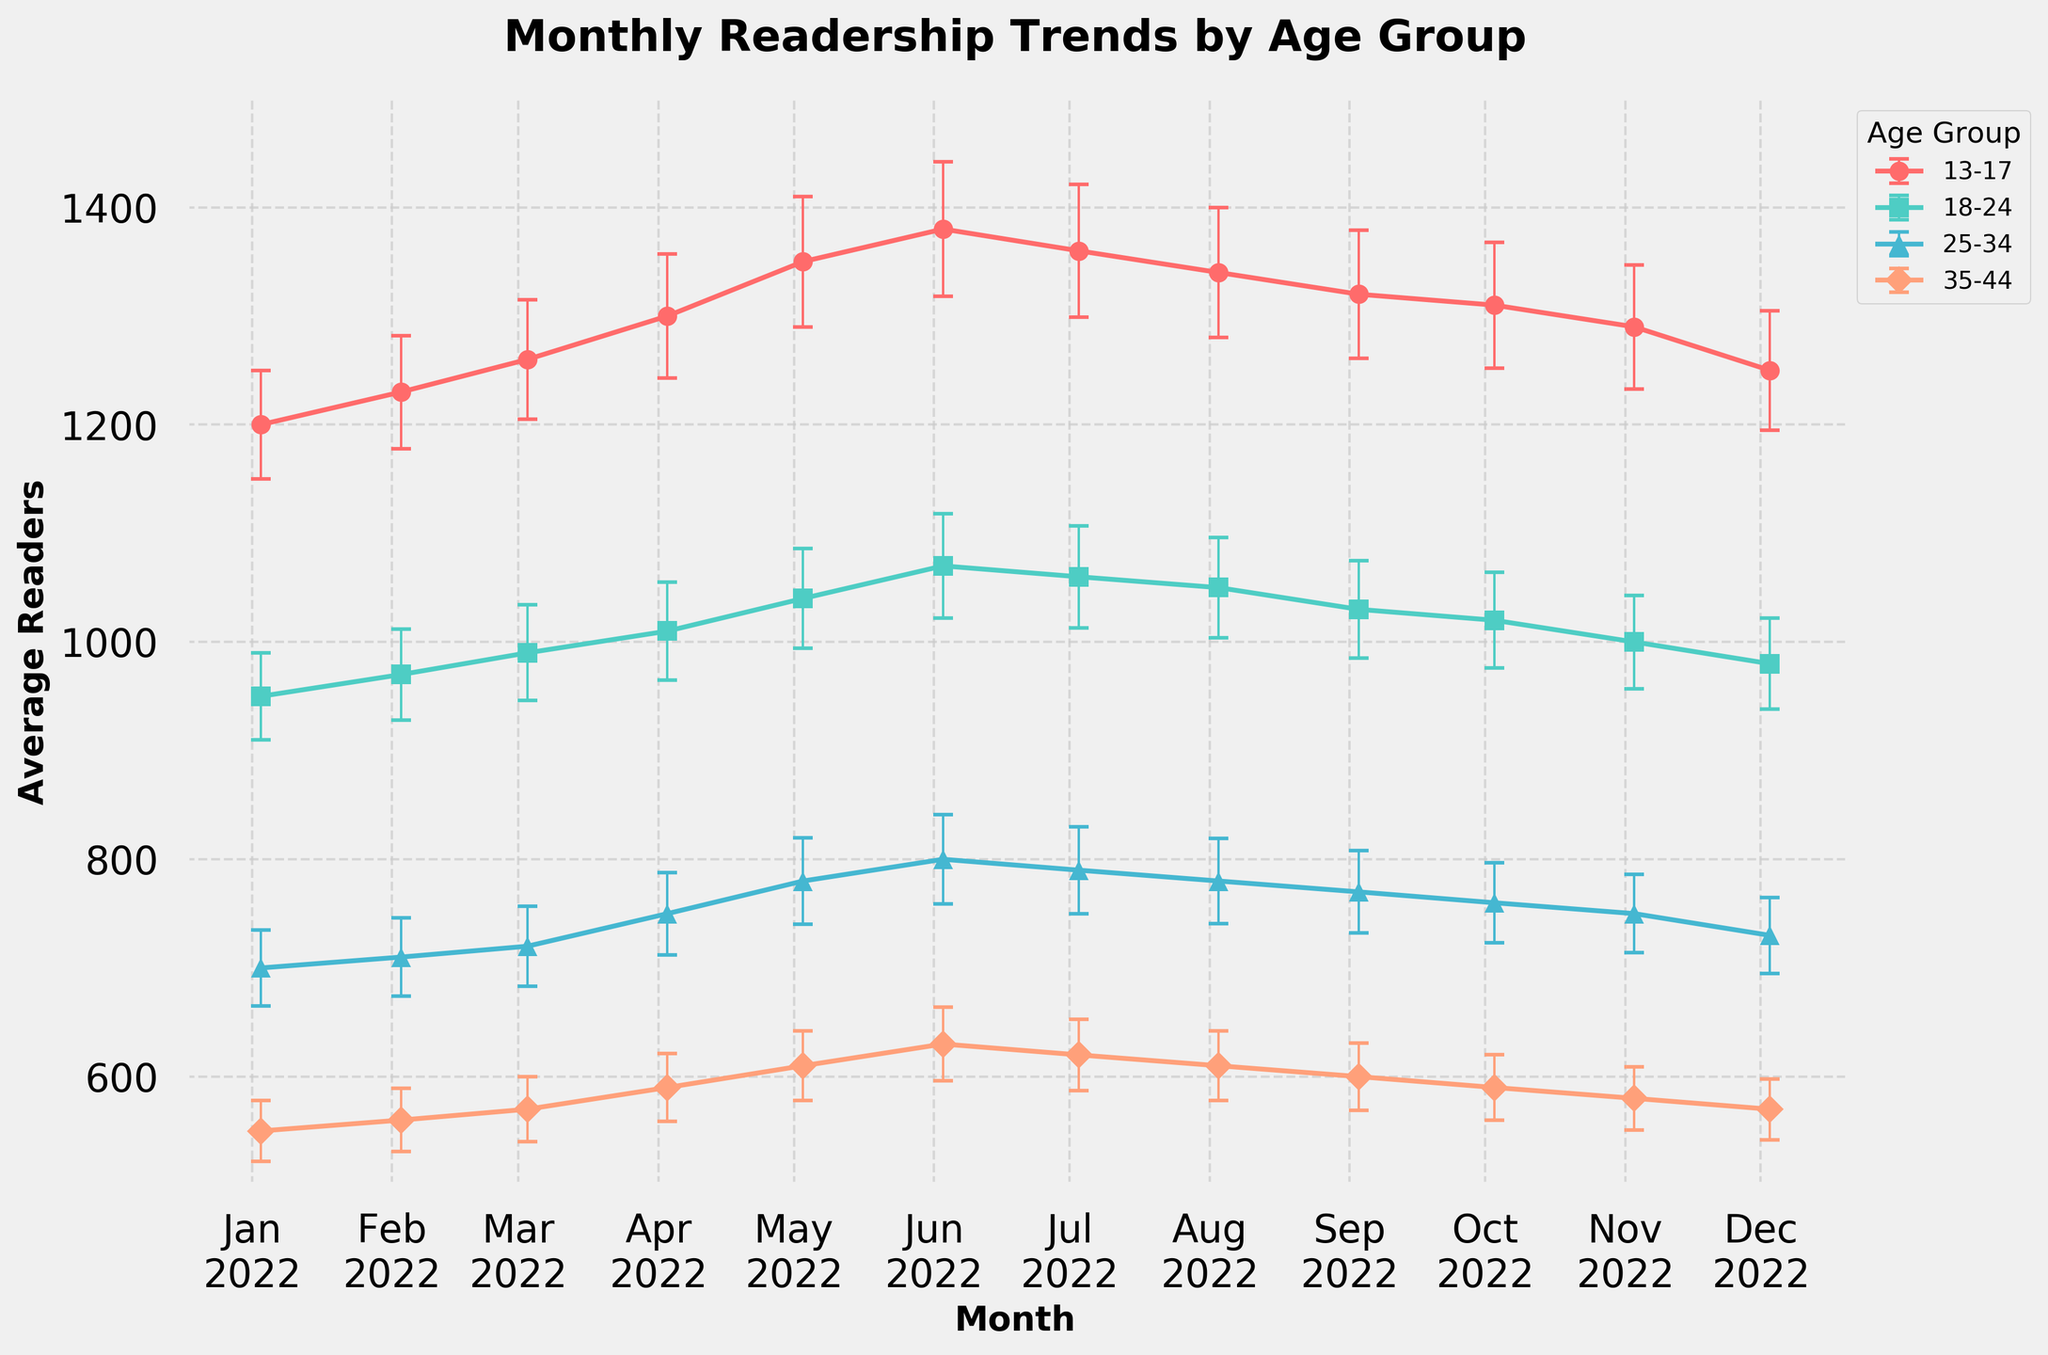What is the title of the figure? The title is usually positioned at the top of the figure in a larger font. The title here is "Monthly Readership Trends by Age Group."
Answer: Monthly Readership Trends by Age Group Which age group consistently had the highest average number of readers each month? By looking at the trend lines, we can see the '13-17' age group is consistently the highest across all months.
Answer: 13-17 In which month did the '18-24' age group have the highest number of average readers? We should follow the line corresponding to the '18-24' age group and find the peak point. The highest number of average readers for this group occurs in June.
Answer: June What was the average readership for the '25-34' age group in May? By following the line and error bars for the '25-34' age group, we find the point for May. The average readership in May for this group is 780.
Answer: 780 By how much did the average readership of the '13-17' age group increase from January to June? Subtract the January value from the June value for the '13-17' age group (1380 - 1200). This increases by 180.
Answer: 180 Which age group had the smallest standard error in December? Look at the error bars for each age group in December. The '13-17' age group has the smallest error bar, hence the smallest standard error.
Answer: 13-17 What age group had the biggest drop in average readership from June to December? We examine the trend for each age group between these two months. The '13-17' age group shows the most significant drop, from 1380 to 1250.
Answer: 13-17 During which month did the '35-44' age group have its highest average readership, and what was this value? Follow the '35-44' trend line and find its peak. The peak occurs in June with an average readership of 630.
Answer: June, 630 